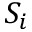Convert formula to latex. <formula><loc_0><loc_0><loc_500><loc_500>S _ { i }</formula> 